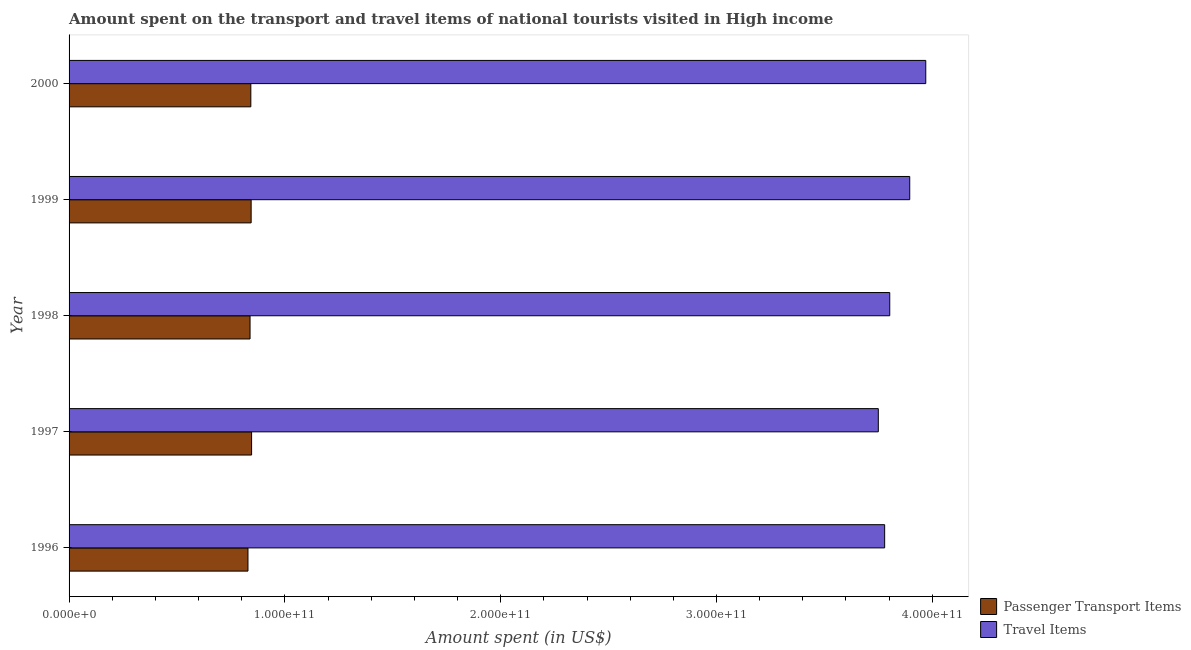Are the number of bars per tick equal to the number of legend labels?
Your response must be concise. Yes. Are the number of bars on each tick of the Y-axis equal?
Offer a terse response. Yes. In how many cases, is the number of bars for a given year not equal to the number of legend labels?
Your response must be concise. 0. What is the amount spent in travel items in 1996?
Provide a succinct answer. 3.78e+11. Across all years, what is the maximum amount spent in travel items?
Your answer should be compact. 3.97e+11. Across all years, what is the minimum amount spent on passenger transport items?
Give a very brief answer. 8.29e+1. In which year was the amount spent on passenger transport items maximum?
Your response must be concise. 1997. What is the total amount spent on passenger transport items in the graph?
Make the answer very short. 4.20e+11. What is the difference between the amount spent on passenger transport items in 1997 and that in 2000?
Keep it short and to the point. 3.56e+08. What is the difference between the amount spent in travel items in 1998 and the amount spent on passenger transport items in 2000?
Your answer should be very brief. 2.96e+11. What is the average amount spent on passenger transport items per year?
Provide a succinct answer. 8.40e+1. In the year 1998, what is the difference between the amount spent on passenger transport items and amount spent in travel items?
Give a very brief answer. -2.96e+11. What is the ratio of the amount spent on passenger transport items in 1997 to that in 2000?
Your response must be concise. 1. Is the amount spent in travel items in 1996 less than that in 1999?
Offer a very short reply. Yes. Is the difference between the amount spent in travel items in 1996 and 1999 greater than the difference between the amount spent on passenger transport items in 1996 and 1999?
Make the answer very short. No. What is the difference between the highest and the second highest amount spent on passenger transport items?
Offer a terse response. 2.09e+08. What is the difference between the highest and the lowest amount spent on passenger transport items?
Give a very brief answer. 1.68e+09. In how many years, is the amount spent on passenger transport items greater than the average amount spent on passenger transport items taken over all years?
Your response must be concise. 3. What does the 2nd bar from the top in 1997 represents?
Keep it short and to the point. Passenger Transport Items. What does the 2nd bar from the bottom in 1997 represents?
Give a very brief answer. Travel Items. How many bars are there?
Your answer should be very brief. 10. How many years are there in the graph?
Make the answer very short. 5. What is the difference between two consecutive major ticks on the X-axis?
Your answer should be very brief. 1.00e+11. Does the graph contain any zero values?
Your answer should be very brief. No. Where does the legend appear in the graph?
Give a very brief answer. Bottom right. What is the title of the graph?
Keep it short and to the point. Amount spent on the transport and travel items of national tourists visited in High income. Does "Female labourers" appear as one of the legend labels in the graph?
Your response must be concise. No. What is the label or title of the X-axis?
Keep it short and to the point. Amount spent (in US$). What is the Amount spent (in US$) of Passenger Transport Items in 1996?
Your answer should be very brief. 8.29e+1. What is the Amount spent (in US$) in Travel Items in 1996?
Give a very brief answer. 3.78e+11. What is the Amount spent (in US$) in Passenger Transport Items in 1997?
Give a very brief answer. 8.46e+1. What is the Amount spent (in US$) in Travel Items in 1997?
Provide a succinct answer. 3.75e+11. What is the Amount spent (in US$) of Passenger Transport Items in 1998?
Your response must be concise. 8.39e+1. What is the Amount spent (in US$) of Travel Items in 1998?
Make the answer very short. 3.80e+11. What is the Amount spent (in US$) of Passenger Transport Items in 1999?
Give a very brief answer. 8.44e+1. What is the Amount spent (in US$) of Travel Items in 1999?
Your answer should be very brief. 3.90e+11. What is the Amount spent (in US$) of Passenger Transport Items in 2000?
Provide a succinct answer. 8.42e+1. What is the Amount spent (in US$) of Travel Items in 2000?
Your answer should be very brief. 3.97e+11. Across all years, what is the maximum Amount spent (in US$) of Passenger Transport Items?
Ensure brevity in your answer.  8.46e+1. Across all years, what is the maximum Amount spent (in US$) in Travel Items?
Provide a succinct answer. 3.97e+11. Across all years, what is the minimum Amount spent (in US$) of Passenger Transport Items?
Offer a terse response. 8.29e+1. Across all years, what is the minimum Amount spent (in US$) in Travel Items?
Make the answer very short. 3.75e+11. What is the total Amount spent (in US$) of Passenger Transport Items in the graph?
Keep it short and to the point. 4.20e+11. What is the total Amount spent (in US$) in Travel Items in the graph?
Offer a terse response. 1.92e+12. What is the difference between the Amount spent (in US$) of Passenger Transport Items in 1996 and that in 1997?
Ensure brevity in your answer.  -1.68e+09. What is the difference between the Amount spent (in US$) in Travel Items in 1996 and that in 1997?
Your answer should be very brief. 2.94e+09. What is the difference between the Amount spent (in US$) in Passenger Transport Items in 1996 and that in 1998?
Make the answer very short. -9.62e+08. What is the difference between the Amount spent (in US$) in Travel Items in 1996 and that in 1998?
Give a very brief answer. -2.36e+09. What is the difference between the Amount spent (in US$) of Passenger Transport Items in 1996 and that in 1999?
Offer a very short reply. -1.47e+09. What is the difference between the Amount spent (in US$) in Travel Items in 1996 and that in 1999?
Offer a very short reply. -1.16e+1. What is the difference between the Amount spent (in US$) of Passenger Transport Items in 1996 and that in 2000?
Keep it short and to the point. -1.32e+09. What is the difference between the Amount spent (in US$) of Travel Items in 1996 and that in 2000?
Offer a terse response. -1.91e+1. What is the difference between the Amount spent (in US$) of Passenger Transport Items in 1997 and that in 1998?
Offer a terse response. 7.16e+08. What is the difference between the Amount spent (in US$) in Travel Items in 1997 and that in 1998?
Offer a terse response. -5.30e+09. What is the difference between the Amount spent (in US$) in Passenger Transport Items in 1997 and that in 1999?
Your response must be concise. 2.09e+08. What is the difference between the Amount spent (in US$) of Travel Items in 1997 and that in 1999?
Provide a succinct answer. -1.46e+1. What is the difference between the Amount spent (in US$) of Passenger Transport Items in 1997 and that in 2000?
Provide a succinct answer. 3.56e+08. What is the difference between the Amount spent (in US$) of Travel Items in 1997 and that in 2000?
Offer a terse response. -2.20e+1. What is the difference between the Amount spent (in US$) of Passenger Transport Items in 1998 and that in 1999?
Provide a short and direct response. -5.07e+08. What is the difference between the Amount spent (in US$) of Travel Items in 1998 and that in 1999?
Offer a terse response. -9.26e+09. What is the difference between the Amount spent (in US$) of Passenger Transport Items in 1998 and that in 2000?
Keep it short and to the point. -3.60e+08. What is the difference between the Amount spent (in US$) of Travel Items in 1998 and that in 2000?
Provide a short and direct response. -1.67e+1. What is the difference between the Amount spent (in US$) in Passenger Transport Items in 1999 and that in 2000?
Offer a very short reply. 1.47e+08. What is the difference between the Amount spent (in US$) of Travel Items in 1999 and that in 2000?
Offer a terse response. -7.43e+09. What is the difference between the Amount spent (in US$) of Passenger Transport Items in 1996 and the Amount spent (in US$) of Travel Items in 1997?
Provide a short and direct response. -2.92e+11. What is the difference between the Amount spent (in US$) of Passenger Transport Items in 1996 and the Amount spent (in US$) of Travel Items in 1998?
Ensure brevity in your answer.  -2.97e+11. What is the difference between the Amount spent (in US$) in Passenger Transport Items in 1996 and the Amount spent (in US$) in Travel Items in 1999?
Your answer should be compact. -3.07e+11. What is the difference between the Amount spent (in US$) in Passenger Transport Items in 1996 and the Amount spent (in US$) in Travel Items in 2000?
Your answer should be very brief. -3.14e+11. What is the difference between the Amount spent (in US$) of Passenger Transport Items in 1997 and the Amount spent (in US$) of Travel Items in 1998?
Ensure brevity in your answer.  -2.96e+11. What is the difference between the Amount spent (in US$) of Passenger Transport Items in 1997 and the Amount spent (in US$) of Travel Items in 1999?
Offer a very short reply. -3.05e+11. What is the difference between the Amount spent (in US$) in Passenger Transport Items in 1997 and the Amount spent (in US$) in Travel Items in 2000?
Your response must be concise. -3.12e+11. What is the difference between the Amount spent (in US$) of Passenger Transport Items in 1998 and the Amount spent (in US$) of Travel Items in 1999?
Your answer should be compact. -3.06e+11. What is the difference between the Amount spent (in US$) in Passenger Transport Items in 1998 and the Amount spent (in US$) in Travel Items in 2000?
Your answer should be very brief. -3.13e+11. What is the difference between the Amount spent (in US$) of Passenger Transport Items in 1999 and the Amount spent (in US$) of Travel Items in 2000?
Ensure brevity in your answer.  -3.13e+11. What is the average Amount spent (in US$) of Passenger Transport Items per year?
Provide a short and direct response. 8.40e+1. What is the average Amount spent (in US$) in Travel Items per year?
Your answer should be very brief. 3.84e+11. In the year 1996, what is the difference between the Amount spent (in US$) of Passenger Transport Items and Amount spent (in US$) of Travel Items?
Your answer should be compact. -2.95e+11. In the year 1997, what is the difference between the Amount spent (in US$) of Passenger Transport Items and Amount spent (in US$) of Travel Items?
Offer a very short reply. -2.90e+11. In the year 1998, what is the difference between the Amount spent (in US$) in Passenger Transport Items and Amount spent (in US$) in Travel Items?
Provide a succinct answer. -2.96e+11. In the year 1999, what is the difference between the Amount spent (in US$) in Passenger Transport Items and Amount spent (in US$) in Travel Items?
Provide a succinct answer. -3.05e+11. In the year 2000, what is the difference between the Amount spent (in US$) of Passenger Transport Items and Amount spent (in US$) of Travel Items?
Offer a very short reply. -3.13e+11. What is the ratio of the Amount spent (in US$) in Passenger Transport Items in 1996 to that in 1997?
Give a very brief answer. 0.98. What is the ratio of the Amount spent (in US$) in Passenger Transport Items in 1996 to that in 1998?
Ensure brevity in your answer.  0.99. What is the ratio of the Amount spent (in US$) in Travel Items in 1996 to that in 1998?
Your answer should be very brief. 0.99. What is the ratio of the Amount spent (in US$) of Passenger Transport Items in 1996 to that in 1999?
Your answer should be very brief. 0.98. What is the ratio of the Amount spent (in US$) in Travel Items in 1996 to that in 1999?
Keep it short and to the point. 0.97. What is the ratio of the Amount spent (in US$) of Passenger Transport Items in 1996 to that in 2000?
Offer a terse response. 0.98. What is the ratio of the Amount spent (in US$) of Travel Items in 1996 to that in 2000?
Offer a terse response. 0.95. What is the ratio of the Amount spent (in US$) of Passenger Transport Items in 1997 to that in 1998?
Ensure brevity in your answer.  1.01. What is the ratio of the Amount spent (in US$) of Travel Items in 1997 to that in 1998?
Offer a terse response. 0.99. What is the ratio of the Amount spent (in US$) in Travel Items in 1997 to that in 1999?
Ensure brevity in your answer.  0.96. What is the ratio of the Amount spent (in US$) in Passenger Transport Items in 1997 to that in 2000?
Your answer should be compact. 1. What is the ratio of the Amount spent (in US$) in Travel Items in 1997 to that in 2000?
Provide a succinct answer. 0.94. What is the ratio of the Amount spent (in US$) in Passenger Transport Items in 1998 to that in 1999?
Your response must be concise. 0.99. What is the ratio of the Amount spent (in US$) of Travel Items in 1998 to that in 1999?
Offer a very short reply. 0.98. What is the ratio of the Amount spent (in US$) in Passenger Transport Items in 1998 to that in 2000?
Make the answer very short. 1. What is the ratio of the Amount spent (in US$) in Travel Items in 1998 to that in 2000?
Ensure brevity in your answer.  0.96. What is the ratio of the Amount spent (in US$) in Travel Items in 1999 to that in 2000?
Your answer should be compact. 0.98. What is the difference between the highest and the second highest Amount spent (in US$) of Passenger Transport Items?
Make the answer very short. 2.09e+08. What is the difference between the highest and the second highest Amount spent (in US$) of Travel Items?
Your answer should be compact. 7.43e+09. What is the difference between the highest and the lowest Amount spent (in US$) in Passenger Transport Items?
Provide a short and direct response. 1.68e+09. What is the difference between the highest and the lowest Amount spent (in US$) in Travel Items?
Your answer should be very brief. 2.20e+1. 